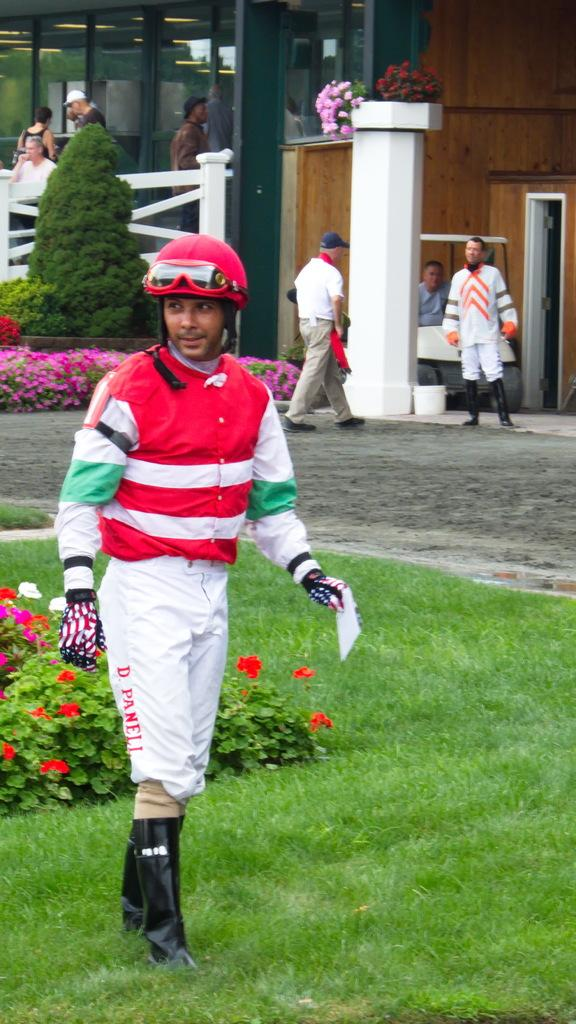What is the person in the image standing on? The person is standing on the grass. What type of vegetation can be seen in the image? There are flowers and plants in the image. How many people are visible in the image? There is one person standing on the grass and a few people at the back of the image. What type of structure is present in the image? There is a building in the image. What can be seen inside the building? Lights are visible in the building. Is there an earthquake happening in the image? There is no indication of an earthquake in the image. What point is the person trying to make in the image? The image does not depict a specific point or message being conveyed by the person. 